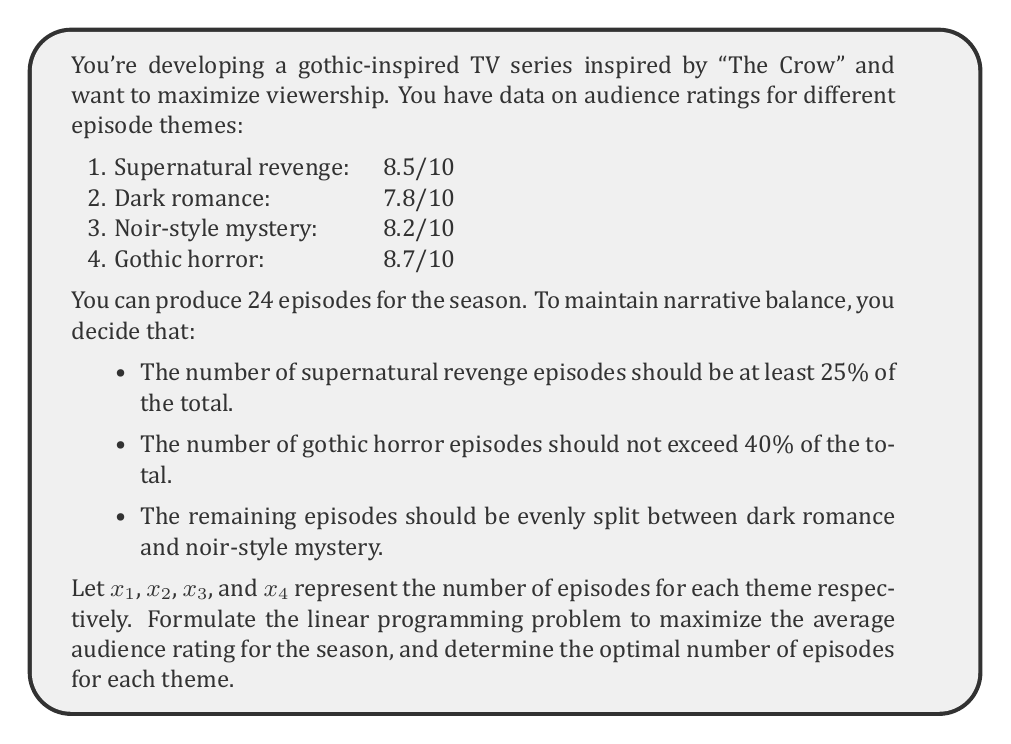Teach me how to tackle this problem. Let's approach this step-by-step:

1) First, we need to set up our objective function. We want to maximize the average rating, which can be expressed as:

   $$ \text{Maximize } Z = \frac{8.5x_1 + 7.8x_2 + 8.2x_3 + 8.7x_4}{24} $$

2) Now, let's set up our constraints:

   a) Total number of episodes:
      $$ x_1 + x_2 + x_3 + x_4 = 24 $$

   b) Supernatural revenge episodes should be at least 25% of the total:
      $$ x_1 \geq 0.25 \times 24 = 6 $$

   c) Gothic horror episodes should not exceed 40% of the total:
      $$ x_4 \leq 0.40 \times 24 = 9.6 $$

   d) Dark romance and noir-style mystery should be equal:
      $$ x_2 = x_3 $$

   e) Non-negativity constraints:
      $$ x_1, x_2, x_3, x_4 \geq 0 $$

3) Simplifying our objective function by multiplying both sides by 24:

   $$ \text{Maximize } 24Z = 8.5x_1 + 7.8x_2 + 8.2x_3 + 8.7x_4 $$

4) Now we have a standard linear programming problem. We can solve this using the simplex method or linear programming software.

5) The optimal solution is:
   $x_1 = 8$, $x_2 = 3$, $x_3 = 3$, $x_4 = 10$

6) This gives us a maximum average rating of:

   $$ Z = \frac{8.5(8) + 7.8(3) + 8.2(3) + 8.7(10)}{24} = 8.45 $$

Therefore, to maximize the average audience rating, you should produce 8 supernatural revenge episodes, 3 dark romance episodes, 3 noir-style mystery episodes, and 10 gothic horror episodes.
Answer: Optimal number of episodes:
Supernatural revenge: 8
Dark romance: 3
Noir-style mystery: 3
Gothic horror: 10
Maximum average rating: 8.45/10 